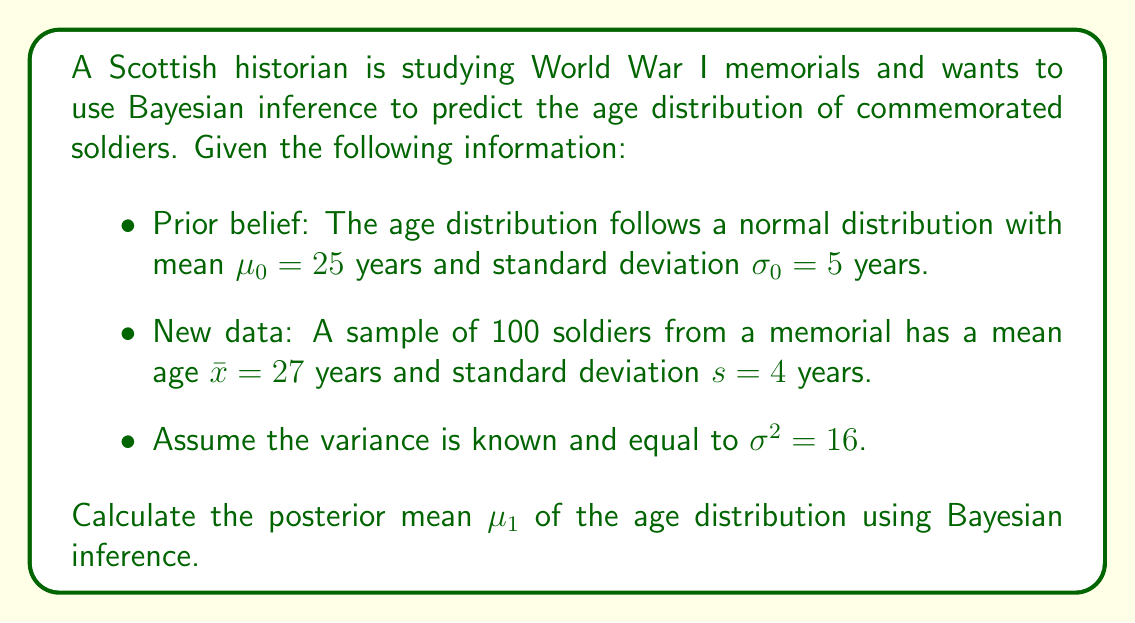Could you help me with this problem? To solve this problem using Bayesian inference, we'll use the formula for updating the mean of a normal distribution with known variance:

$$\mu_1 = \frac{\frac{\mu_0}{\sigma_0^2} + \frac{n\bar{x}}{\sigma^2}}{\frac{1}{\sigma_0^2} + \frac{n}{\sigma^2}}$$

Where:
$\mu_0 = 25$ (prior mean)
$\sigma_0 = 5$ (prior standard deviation)
$\bar{x} = 27$ (sample mean)
$n = 100$ (sample size)
$\sigma^2 = 16$ (known variance)

Step 1: Calculate the reciprocal of the prior variance:
$$\frac{1}{\sigma_0^2} = \frac{1}{5^2} = \frac{1}{25}$$

Step 2: Calculate the reciprocal of the known variance:
$$\frac{1}{\sigma^2} = \frac{1}{16}$$

Step 3: Calculate the numerator of the formula:
$$\frac{\mu_0}{\sigma_0^2} + \frac{n\bar{x}}{\sigma^2} = \frac{25}{25} + \frac{100 \cdot 27}{16} = 1 + 168.75 = 169.75$$

Step 4: Calculate the denominator of the formula:
$$\frac{1}{\sigma_0^2} + \frac{n}{\sigma^2} = \frac{1}{25} + \frac{100}{16} = 0.04 + 6.25 = 6.29$$

Step 5: Calculate the posterior mean:
$$\mu_1 = \frac{169.75}{6.29} \approx 26.99$$

Therefore, the posterior mean age of soldiers commemorated on the World War I memorial is approximately 26.99 years.
Answer: 26.99 years 